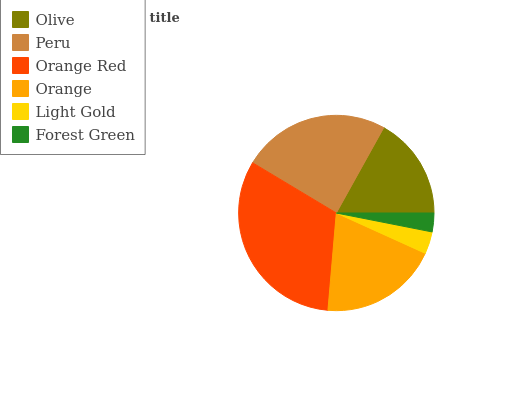Is Forest Green the minimum?
Answer yes or no. Yes. Is Orange Red the maximum?
Answer yes or no. Yes. Is Peru the minimum?
Answer yes or no. No. Is Peru the maximum?
Answer yes or no. No. Is Peru greater than Olive?
Answer yes or no. Yes. Is Olive less than Peru?
Answer yes or no. Yes. Is Olive greater than Peru?
Answer yes or no. No. Is Peru less than Olive?
Answer yes or no. No. Is Orange the high median?
Answer yes or no. Yes. Is Olive the low median?
Answer yes or no. Yes. Is Light Gold the high median?
Answer yes or no. No. Is Forest Green the low median?
Answer yes or no. No. 